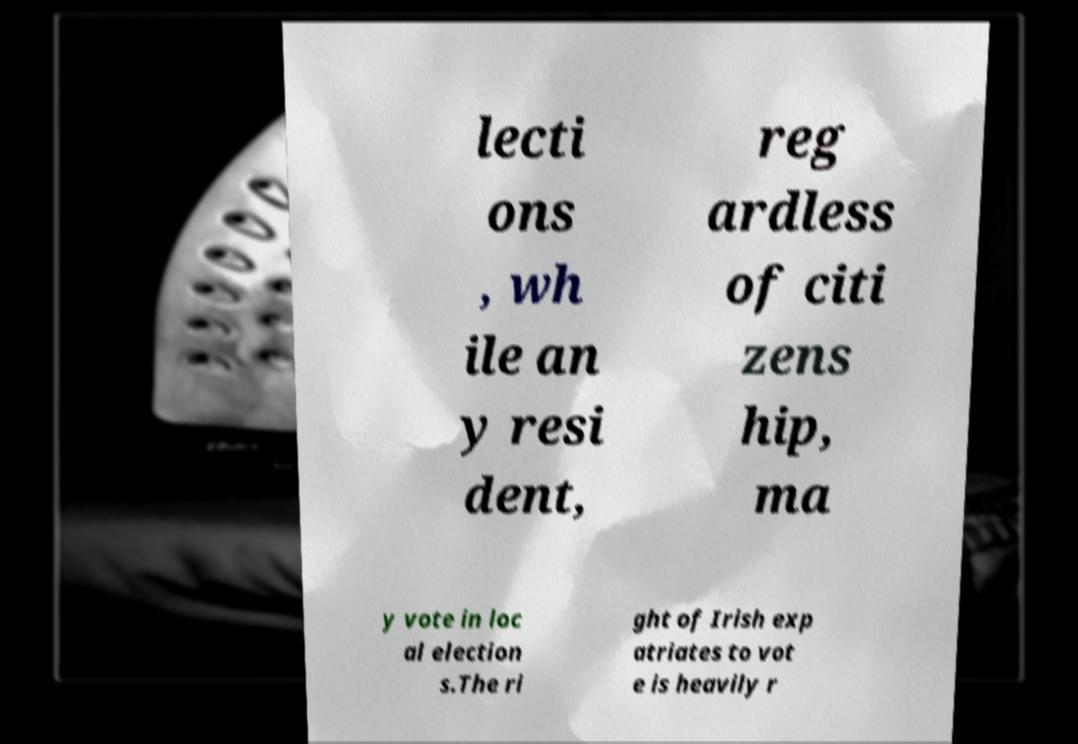I need the written content from this picture converted into text. Can you do that? lecti ons , wh ile an y resi dent, reg ardless of citi zens hip, ma y vote in loc al election s.The ri ght of Irish exp atriates to vot e is heavily r 